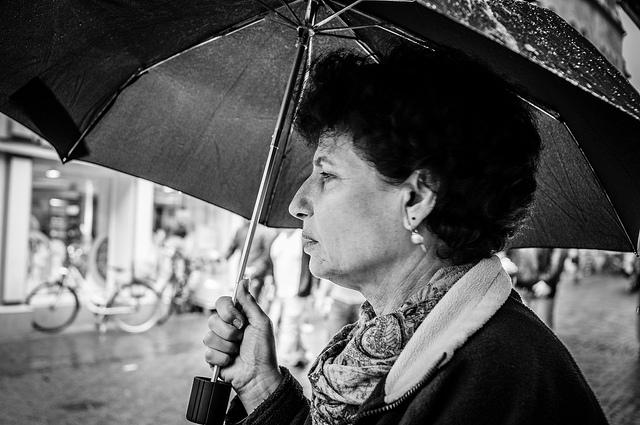What kind of weather is the woman experiencing? rain 